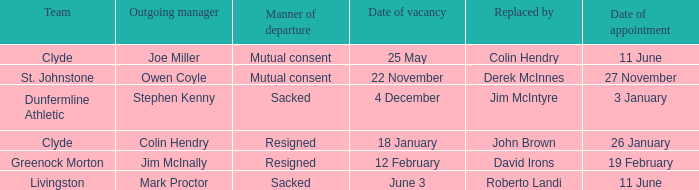Who holds the position of the manager leaving livingston? Mark Proctor. 